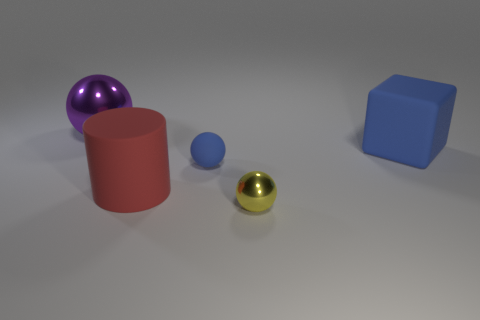How many metallic things are small yellow objects or large blue blocks?
Make the answer very short. 1. There is another rubber thing that is the same color as the small rubber object; what shape is it?
Your answer should be very brief. Cube. What material is the small ball behind the small yellow shiny object?
Make the answer very short. Rubber. How many objects are either tiny blue matte spheres or things behind the big red cylinder?
Offer a very short reply. 3. There is a yellow thing that is the same size as the blue ball; what is its shape?
Provide a short and direct response. Sphere. What number of metal balls have the same color as the large matte cube?
Ensure brevity in your answer.  0. Are the tiny sphere that is in front of the big cylinder and the blue ball made of the same material?
Provide a succinct answer. No. What is the shape of the purple metal object?
Make the answer very short. Sphere. How many yellow objects are either metallic objects or matte spheres?
Keep it short and to the point. 1. What number of other objects are there of the same material as the red thing?
Make the answer very short. 2. 